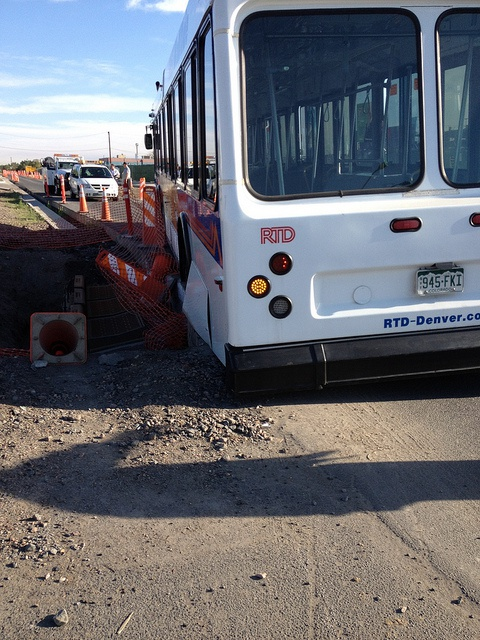Describe the objects in this image and their specific colors. I can see bus in lightblue, darkgray, black, navy, and gray tones, car in lightblue, white, black, darkgray, and gray tones, truck in lightblue, black, gray, lightgray, and darkgray tones, people in lightblue, gray, white, brown, and darkgray tones, and people in lightblue, gray, lightgray, darkgray, and black tones in this image. 